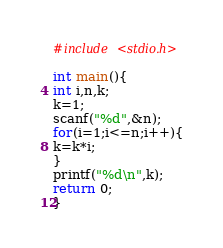Convert code to text. <code><loc_0><loc_0><loc_500><loc_500><_C_>#include <stdio.h>

int main(){
int i,n,k;
k=1;
scanf("%d",&n);
for(i=1;i<=n;i++){
k=k*i;
}
printf("%d\n",k);
return 0;
}</code> 